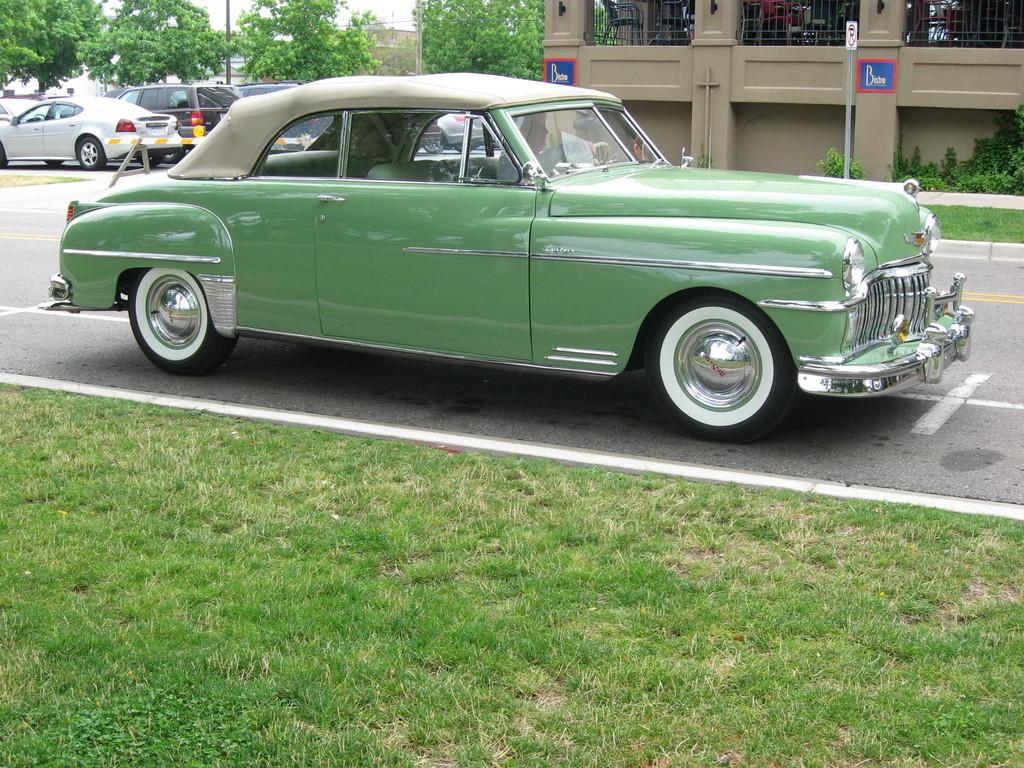What can be seen beside the road in the image? There are cars parked beside the road. What type of vegetation is present around the cars? There are trees around the cars. What structure is located behind the first car? There is a building behind the first car. What arithmetic problem can be solved using the license plate numbers of the cars in the image? There is no information about license plate numbers in the image, so it is not possible to solve any arithmetic problems based on the image. 